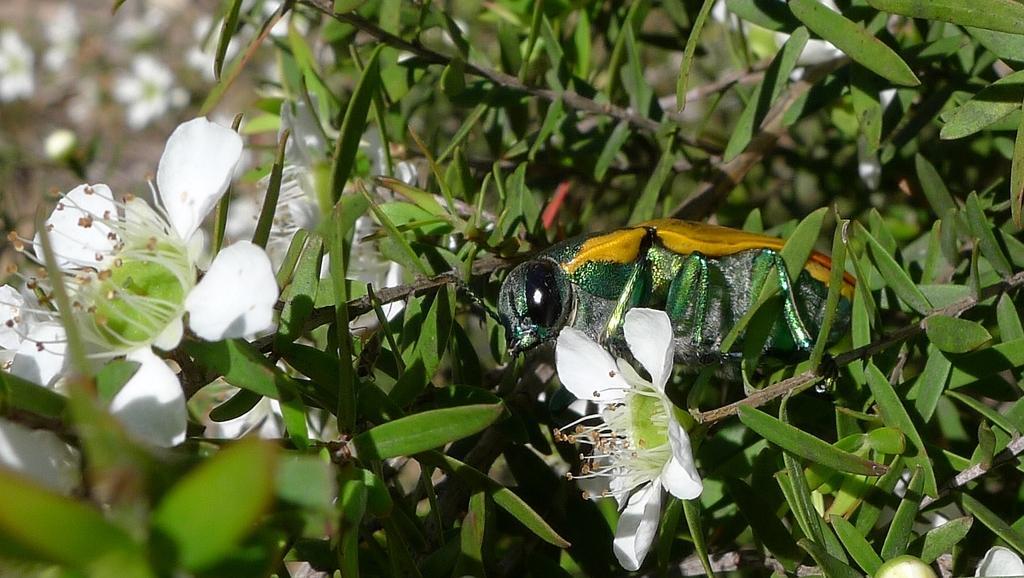Describe this image in one or two sentences. In this image there is a plant truncated, there are flowers on the plant, there is a flower truncated towards the left of the image, there is a flower truncated towards the bottom of the image, there is a flower truncated towards the top of the image, there is an insect on the plant, the background of the image is blurred. 